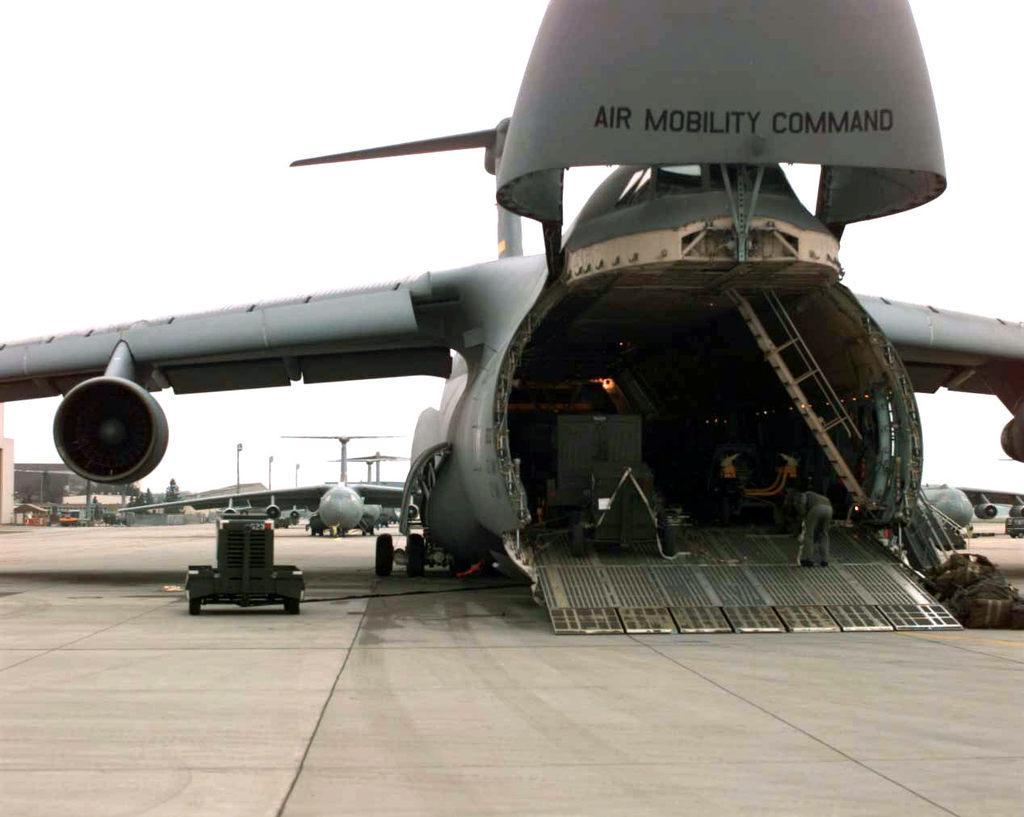In one or two sentences, can you explain what this image depicts? There is a flight. Inside the flight there is a ladder and a person is standing. On the flight something is written. Near to the flight there are bags. In the background there is another flight, poles and sky. Also there is a vehicle near to the flight. 